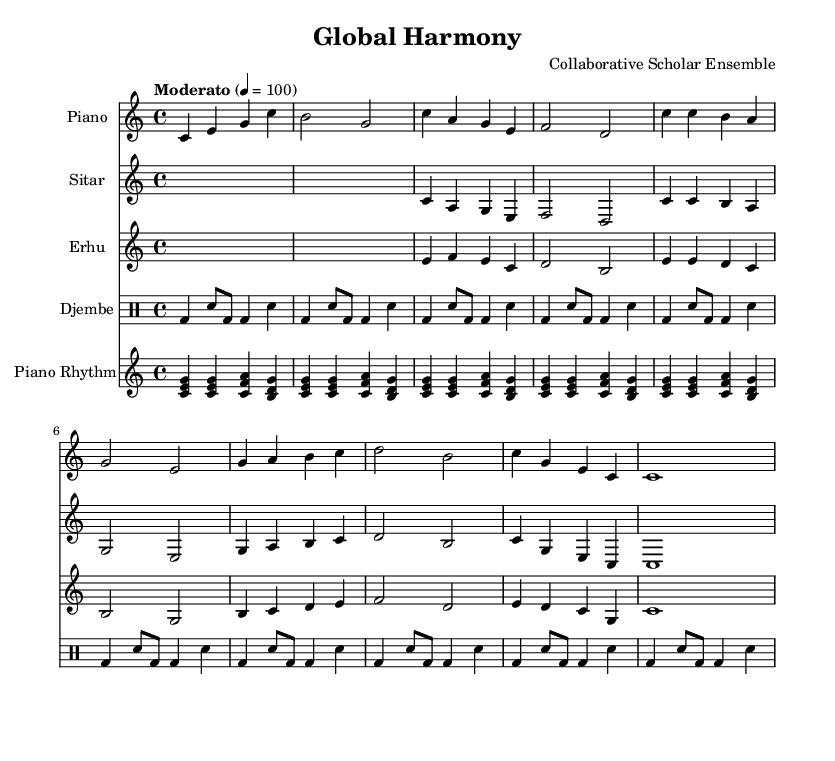What is the key signature of this music? The key signature is indicated by the absence of sharps or flats, confirming that it is in C major.
Answer: C major What is the time signature of the piece? The time signature is displayed at the beginning of the score, showing a 4/4 rhythm.
Answer: 4/4 What is the tempo marking for this music? The tempo marking "Moderato" specifies the tempo, which is set to 100 beats per minute.
Answer: Moderato How many instruments are included in this composition? By counting the distinct staves in the score, we can see there are four instruments: Piano, Sitar, Erhu, and Djembe.
Answer: Four Which section features a solo instrument line? The erhu part can be identified as a distinct solo line, harmonizing with the piano while showcasing its unique sound.
Answer: Erhu In which measure does the chorus start? The chorus can be identified beginning in measure 5, where the structure changes to the more catchy and prominent 'c' motif.
Answer: Measure 5 How does the Djembe contribute to the rhythmic texture? The Djembe employs a repeating pattern with bass and snare drums, enhancing the overall pulse and groove of the fusion piece.
Answer: Rhythmic pulse 